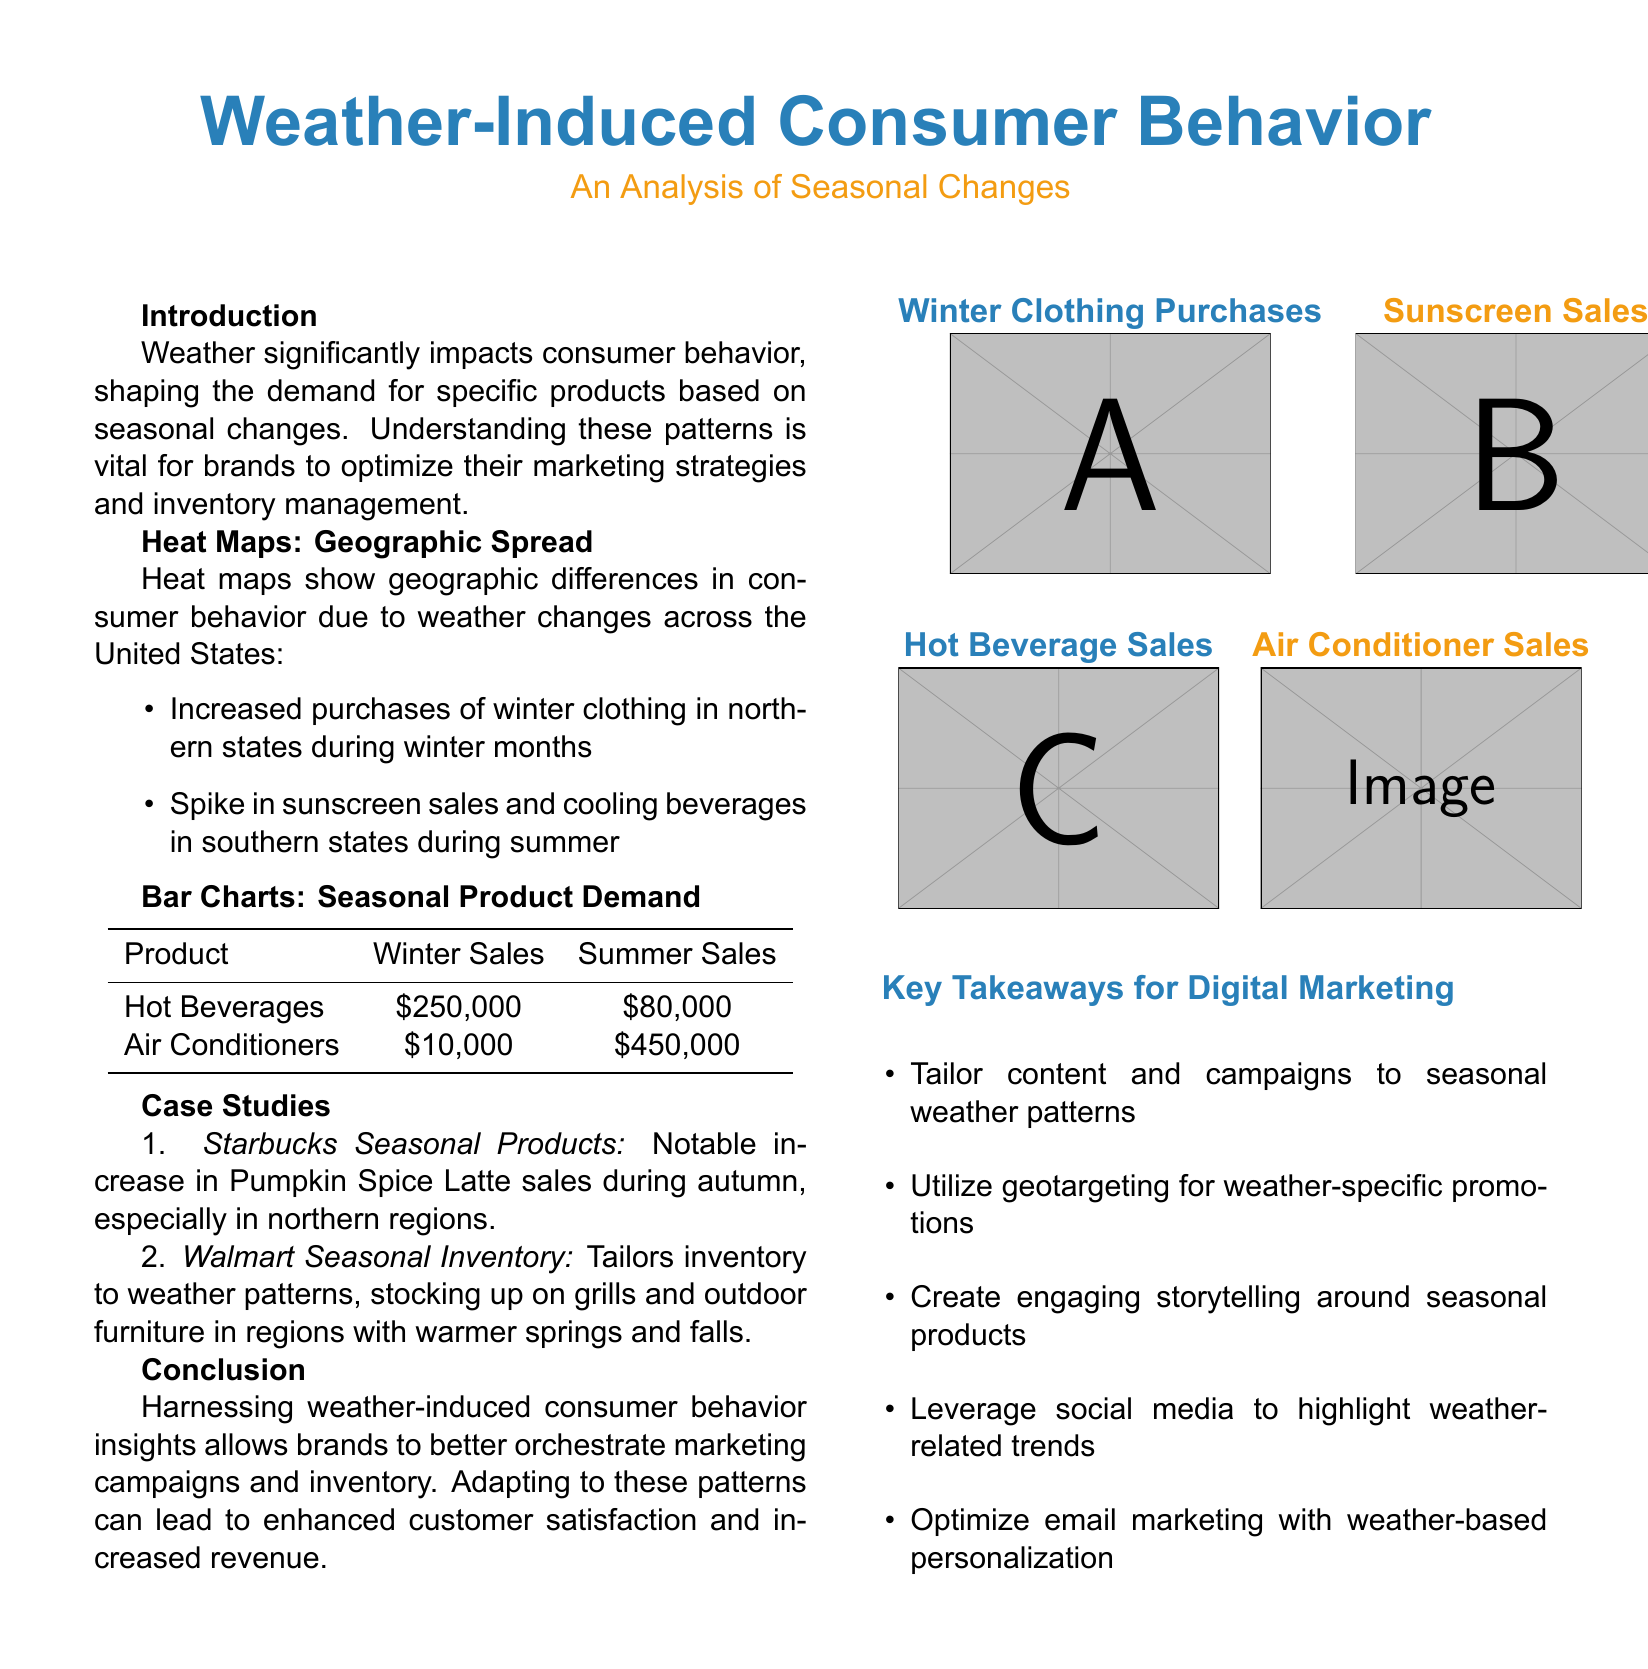What product experiences the highest revenue during winter? The document lists Hot Beverages with winter sales of $250,000, making it the highest revenue product in that season.
Answer: Hot Beverages What is the increase in Pumpkin Spice Latte sales during autumn? The case study mentions a notable increase but does not specify the exact number; however, it indicates significant sales particularly in northern regions.
Answer: Not specified What type of products does Walmart stock in warmer springs? The document states that Walmart tailors inventory to weather patterns, stocking up on grills and outdoor furniture during warmer springs.
Answer: Grills and outdoor furniture What is the summer sales figure for air conditioners? The table provides summer sales figures for air conditioners as $450,000, showing a significant demand in that season.
Answer: $450,000 Which states see increased purchases of winter clothing during which months? The document indicates that northern states experience increased purchases of winter clothing during winter months.
Answer: Northern states, winter months What color represents the bar chart for summer sales? The document presents the summer sales bar chart with the same orange color as used in the title highlighting summer products.
Answer: Orange What is the purpose of the heat maps in the document? The heat maps illustrate geographic differences in consumer behavior due to weather changes across the United States.
Answer: Geographic differences How do weather patterns affect digital marketing strategies according to the document? The document outlines key takeaways, suggesting tailoring content and campaigns to seasonal weather patterns to enhance marketing effectiveness.
Answer: Tailor content and campaigns What theme do the key takeaways for digital marketing emphasize? The key takeaways stress the importance of utilizing weather-related trends and personalization in marketing efforts.
Answer: Weather-related trends and personalization 